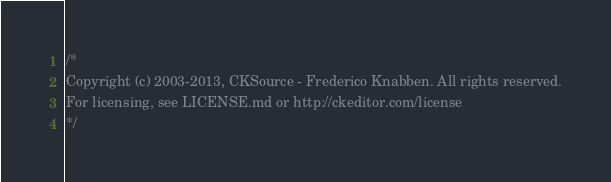Convert code to text. <code><loc_0><loc_0><loc_500><loc_500><_CSS_>/*
Copyright (c) 2003-2013, CKSource - Frederico Knabben. All rights reserved.
For licensing, see LICENSE.md or http://ckeditor.com/license
*/</code> 